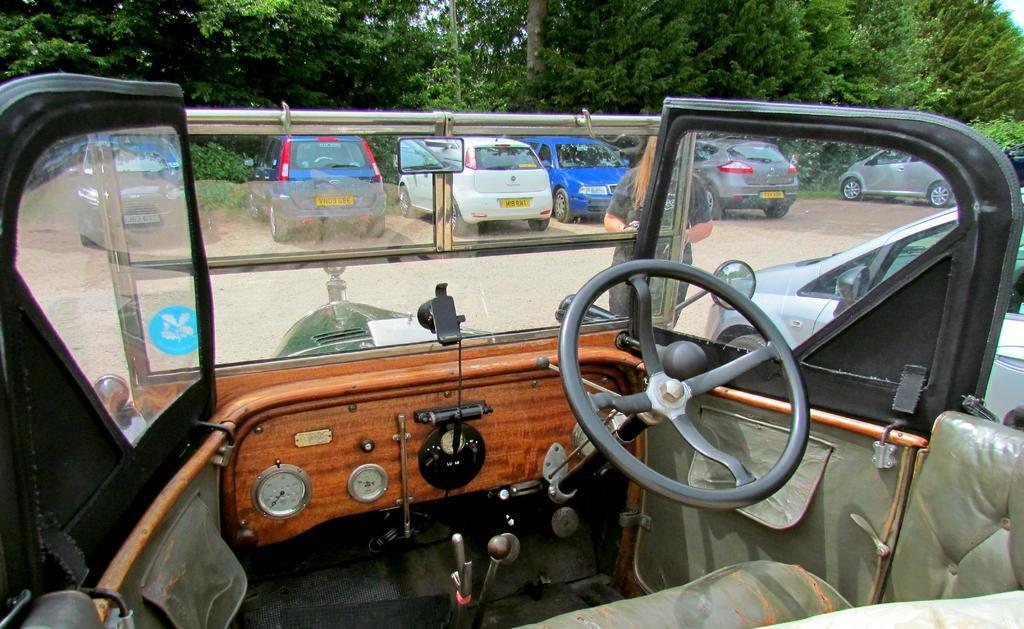Could you give a brief overview of what you see in this image? As we can see in the image there are vehicles, trees and sky. 